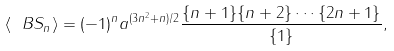<formula> <loc_0><loc_0><loc_500><loc_500>\langle \ B S _ { n } \rangle = ( - 1 ) ^ { n } a ^ { ( 3 n ^ { 2 } + n ) / 2 } \frac { \{ n + 1 \} \{ n + 2 \} \cdots \{ 2 n + 1 \} } { \{ 1 \} } ,</formula> 